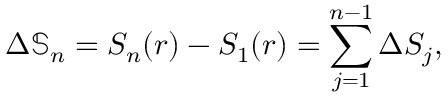<formula> <loc_0><loc_0><loc_500><loc_500>\Delta \mathbb { S } _ { n } = S _ { n } ( r ) - S _ { 1 } ( r ) = \sum _ { j = 1 } ^ { n - 1 } \Delta S _ { j } ,</formula> 